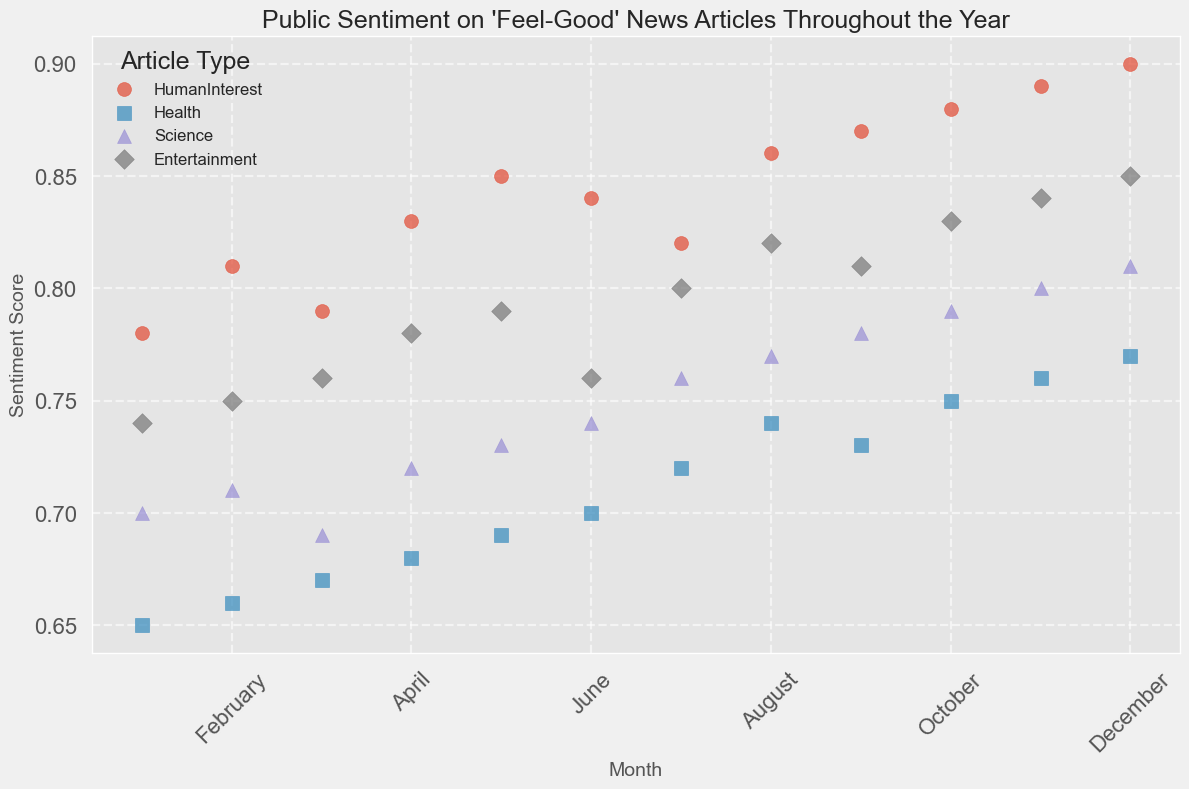Which month has the highest public sentiment score for Human Interest articles? Look at the scatter points associated with Human Interest articles and identify the highest point on the y-axis.
Answer: December Which Article Type has the lowest sentiment score in January? Check the scatter points for January and compare the sentiment scores for each Article Type.
Answer: Health By how much does the sentiment score of Entertainment articles increase from June to July? Find the sentiment scores for Entertainment in June and July and calculate the difference (July score - June score). June: 0.76, July: 0.80, so the difference is 0.80 - 0.76 = 0.04
Answer: 0.04 Which month shows the highest sentiment score across all Article Types? Check each scatter point across all Article Types and identify the month with the highest sentiment score on the y-axis.
Answer: December Compare the sentiment scores of Health and Science articles in April. Which one is higher? Find the sentiment scores for both Health and Science in April and compare them. Health: 0.68, Science: 0.72, so Science is higher.
Answer: Science What is the overall trend of the sentiment scores for Human Interest articles throughout the year? Observe the scatter points for Human Interest articles and note how they change from January to December.
Answer: Increasing Which Article Type has the most significant sentiment score increase from January to December? Calculate the difference between January and December sentiment scores for each Article Type, then find the largest difference. Human Interest: 0.90 - 0.78 = 0.12, Health: 0.77 - 0.65 = 0.12, Science: 0.81 - 0.70 = 0.11, Entertainment: 0.85 - 0.74 = 0.11. Human Interest and Health have the same increase of 0.12.
Answer: Human Interest and Health During which months do Health articles have a lower sentiment score than Science articles? Compare the sentiment scores of Health and Science for each month and identify when Health articles have a lower score.
Answer: January - April, September By how much does the sentiment score for Entertainment articles change from March to September? Find the sentiment scores for Entertainment in March and September and calculate the difference (September score - March score). March: 0.76, September: 0.81, so the difference is 0.81 - 0.76 = 0.05
Answer: 0.05 